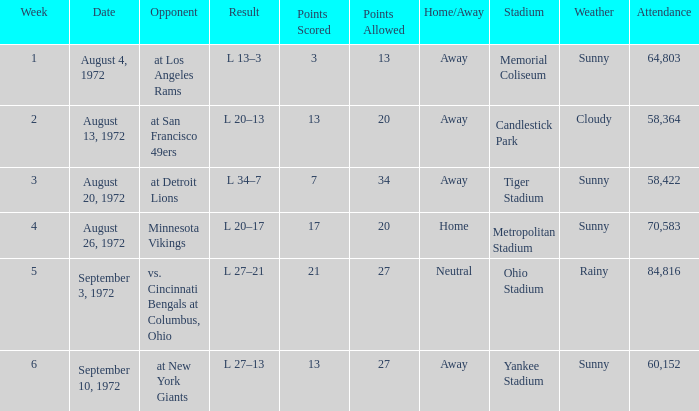How many weeks had an attendance larger than 84,816? 0.0. 